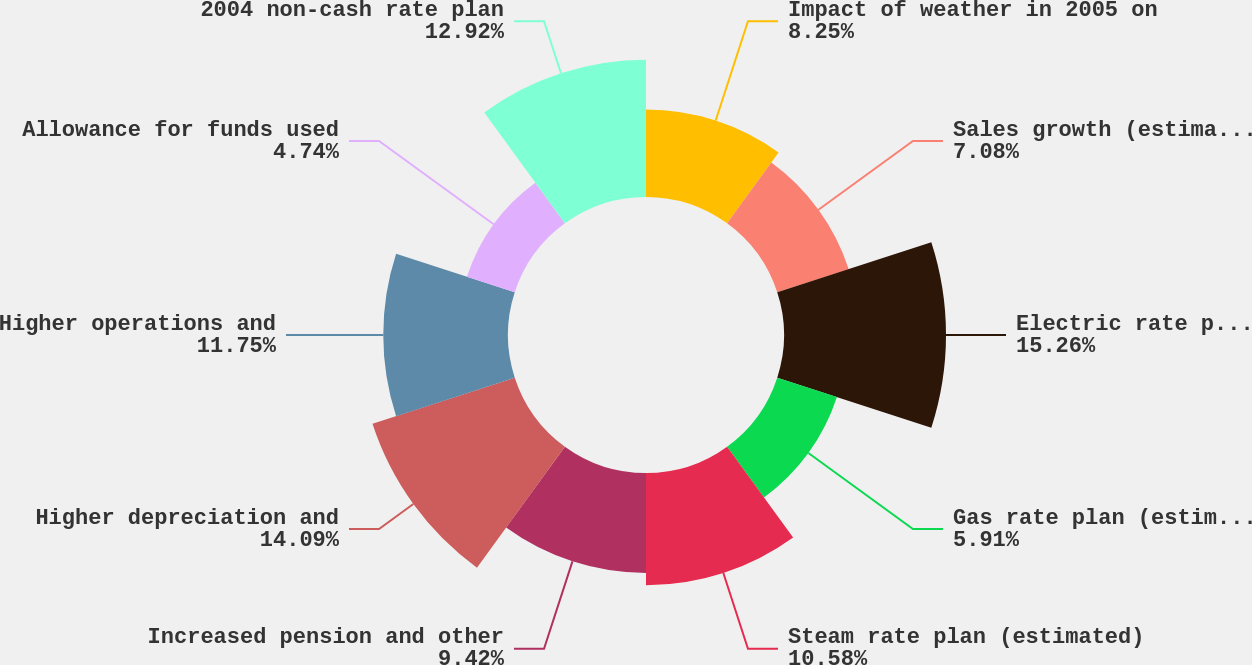Convert chart to OTSL. <chart><loc_0><loc_0><loc_500><loc_500><pie_chart><fcel>Impact of weather in 2005 on<fcel>Sales growth (estimated)<fcel>Electric rate plan (estimated)<fcel>Gas rate plan (estimated)<fcel>Steam rate plan (estimated)<fcel>Increased pension and other<fcel>Higher depreciation and<fcel>Higher operations and<fcel>Allowance for funds used<fcel>2004 non-cash rate plan<nl><fcel>8.25%<fcel>7.08%<fcel>15.26%<fcel>5.91%<fcel>10.58%<fcel>9.42%<fcel>14.09%<fcel>11.75%<fcel>4.74%<fcel>12.92%<nl></chart> 